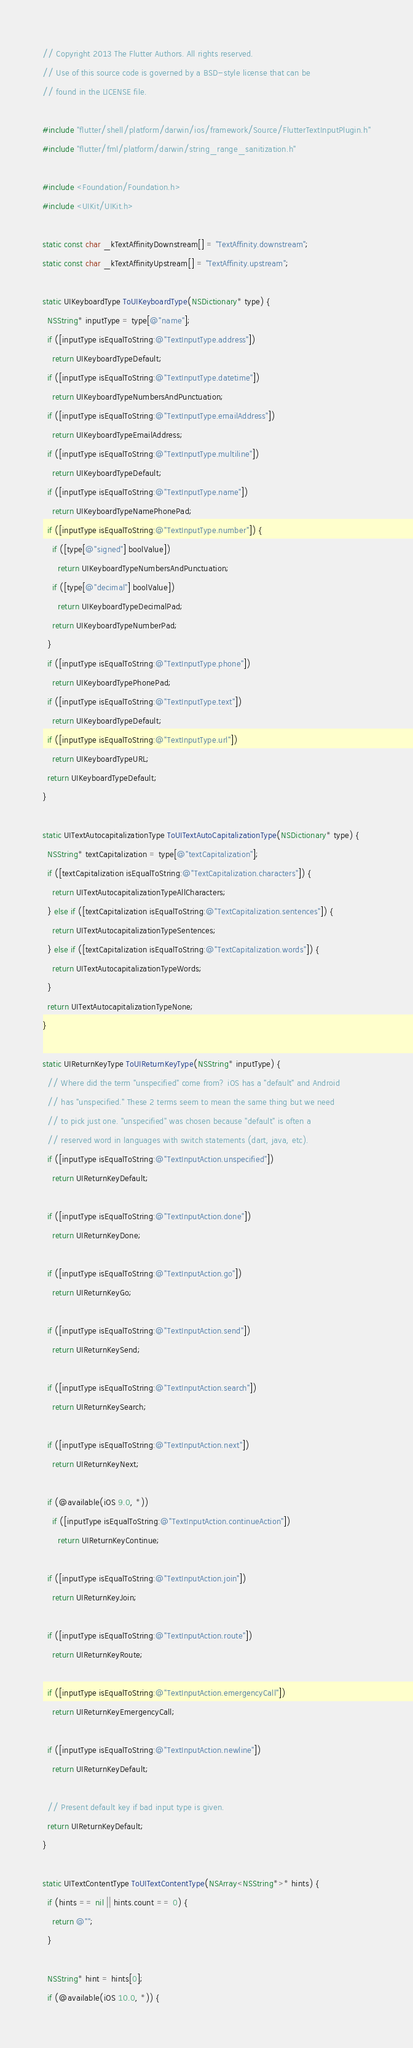<code> <loc_0><loc_0><loc_500><loc_500><_ObjectiveC_>// Copyright 2013 The Flutter Authors. All rights reserved.
// Use of this source code is governed by a BSD-style license that can be
// found in the LICENSE file.

#include "flutter/shell/platform/darwin/ios/framework/Source/FlutterTextInputPlugin.h"
#include "flutter/fml/platform/darwin/string_range_sanitization.h"

#include <Foundation/Foundation.h>
#include <UIKit/UIKit.h>

static const char _kTextAffinityDownstream[] = "TextAffinity.downstream";
static const char _kTextAffinityUpstream[] = "TextAffinity.upstream";

static UIKeyboardType ToUIKeyboardType(NSDictionary* type) {
  NSString* inputType = type[@"name"];
  if ([inputType isEqualToString:@"TextInputType.address"])
    return UIKeyboardTypeDefault;
  if ([inputType isEqualToString:@"TextInputType.datetime"])
    return UIKeyboardTypeNumbersAndPunctuation;
  if ([inputType isEqualToString:@"TextInputType.emailAddress"])
    return UIKeyboardTypeEmailAddress;
  if ([inputType isEqualToString:@"TextInputType.multiline"])
    return UIKeyboardTypeDefault;
  if ([inputType isEqualToString:@"TextInputType.name"])
    return UIKeyboardTypeNamePhonePad;
  if ([inputType isEqualToString:@"TextInputType.number"]) {
    if ([type[@"signed"] boolValue])
      return UIKeyboardTypeNumbersAndPunctuation;
    if ([type[@"decimal"] boolValue])
      return UIKeyboardTypeDecimalPad;
    return UIKeyboardTypeNumberPad;
  }
  if ([inputType isEqualToString:@"TextInputType.phone"])
    return UIKeyboardTypePhonePad;
  if ([inputType isEqualToString:@"TextInputType.text"])
    return UIKeyboardTypeDefault;
  if ([inputType isEqualToString:@"TextInputType.url"])
    return UIKeyboardTypeURL;
  return UIKeyboardTypeDefault;
}

static UITextAutocapitalizationType ToUITextAutoCapitalizationType(NSDictionary* type) {
  NSString* textCapitalization = type[@"textCapitalization"];
  if ([textCapitalization isEqualToString:@"TextCapitalization.characters"]) {
    return UITextAutocapitalizationTypeAllCharacters;
  } else if ([textCapitalization isEqualToString:@"TextCapitalization.sentences"]) {
    return UITextAutocapitalizationTypeSentences;
  } else if ([textCapitalization isEqualToString:@"TextCapitalization.words"]) {
    return UITextAutocapitalizationTypeWords;
  }
  return UITextAutocapitalizationTypeNone;
}

static UIReturnKeyType ToUIReturnKeyType(NSString* inputType) {
  // Where did the term "unspecified" come from? iOS has a "default" and Android
  // has "unspecified." These 2 terms seem to mean the same thing but we need
  // to pick just one. "unspecified" was chosen because "default" is often a
  // reserved word in languages with switch statements (dart, java, etc).
  if ([inputType isEqualToString:@"TextInputAction.unspecified"])
    return UIReturnKeyDefault;

  if ([inputType isEqualToString:@"TextInputAction.done"])
    return UIReturnKeyDone;

  if ([inputType isEqualToString:@"TextInputAction.go"])
    return UIReturnKeyGo;

  if ([inputType isEqualToString:@"TextInputAction.send"])
    return UIReturnKeySend;

  if ([inputType isEqualToString:@"TextInputAction.search"])
    return UIReturnKeySearch;

  if ([inputType isEqualToString:@"TextInputAction.next"])
    return UIReturnKeyNext;

  if (@available(iOS 9.0, *))
    if ([inputType isEqualToString:@"TextInputAction.continueAction"])
      return UIReturnKeyContinue;

  if ([inputType isEqualToString:@"TextInputAction.join"])
    return UIReturnKeyJoin;

  if ([inputType isEqualToString:@"TextInputAction.route"])
    return UIReturnKeyRoute;

  if ([inputType isEqualToString:@"TextInputAction.emergencyCall"])
    return UIReturnKeyEmergencyCall;

  if ([inputType isEqualToString:@"TextInputAction.newline"])
    return UIReturnKeyDefault;

  // Present default key if bad input type is given.
  return UIReturnKeyDefault;
}

static UITextContentType ToUITextContentType(NSArray<NSString*>* hints) {
  if (hints == nil || hints.count == 0) {
    return @"";
  }

  NSString* hint = hints[0];
  if (@available(iOS 10.0, *)) {</code> 